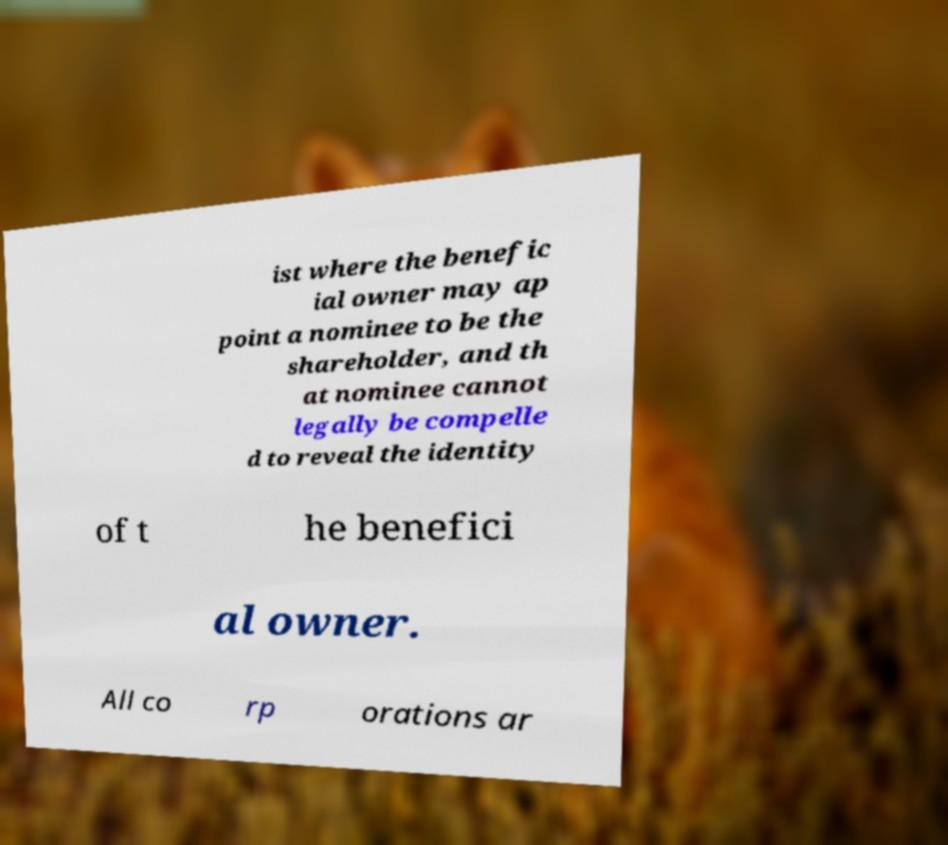There's text embedded in this image that I need extracted. Can you transcribe it verbatim? ist where the benefic ial owner may ap point a nominee to be the shareholder, and th at nominee cannot legally be compelle d to reveal the identity of t he benefici al owner. All co rp orations ar 